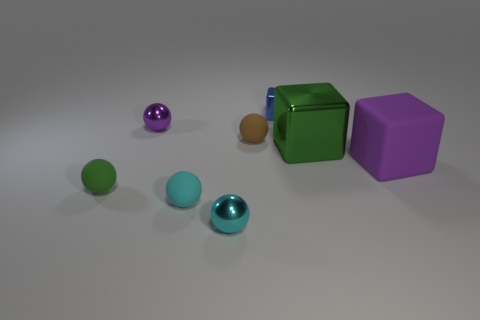Subtract all cyan shiny balls. How many balls are left? 4 Subtract all gray blocks. How many cyan balls are left? 2 Add 1 large matte cylinders. How many objects exist? 9 Subtract all purple spheres. How many spheres are left? 4 Subtract 3 spheres. How many spheres are left? 2 Subtract all balls. How many objects are left? 3 Add 8 yellow rubber spheres. How many yellow rubber spheres exist? 8 Subtract 0 red cubes. How many objects are left? 8 Subtract all red cubes. Subtract all green cylinders. How many cubes are left? 3 Subtract all green things. Subtract all small brown spheres. How many objects are left? 5 